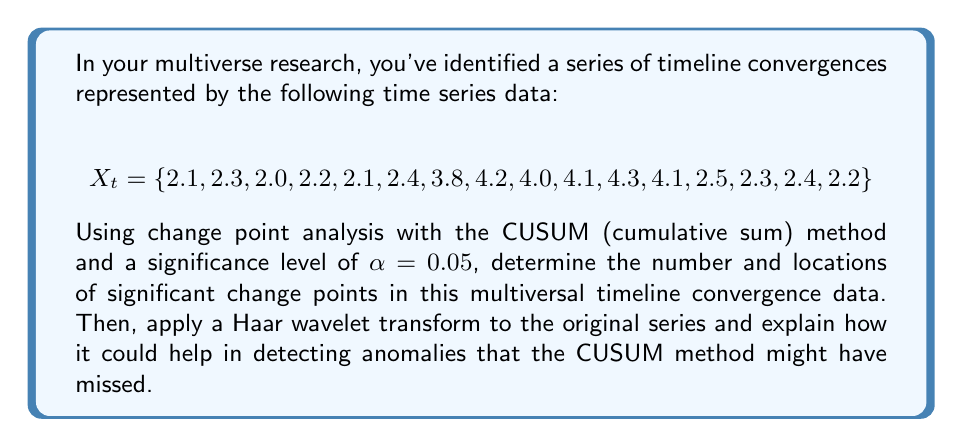Solve this math problem. To solve this problem, we'll follow these steps:

1. Perform CUSUM change point analysis
2. Apply Haar wavelet transform
3. Interpret the results

Step 1: CUSUM Change Point Analysis

The CUSUM method calculates the cumulative sum of deviations from the mean:

$$S_0 = 0$$
$$S_t = S_{t-1} + (X_t - \bar{X})$$

where $\bar{X}$ is the mean of the series.

First, calculate the mean:
$$\bar{X} = \frac{1}{16}\sum_{t=1}^{16} X_t = 2.9375$$

Now, calculate the CUSUM values:

$$S_1 = 0 + (2.1 - 2.9375) = -0.8375$$
$$S_2 = -0.8375 + (2.3 - 2.9375) = -1.475$$
...
$$S_{16} = -13.475 + (2.2 - 2.9375) = -14.2125$$

The test statistic is:

$$S_{diff} = \max(S_t) - \min(S_t)$$

In this case, $S_{diff} = 1.5875 - (-14.2125) = 15.8$$

To determine if this is significant, we compare it to a critical value. For $\alpha = 0.05$ and $n = 16$, the critical value is approximately 1.36 * $\sqrt{n}$ = 5.44.

Since 15.8 > 5.44, we reject the null hypothesis of no change point.

To locate the change point, find the index where $|S_t|$ is maximum. This occurs at $t = 6$, indicating a change point between the 6th and 7th observations.

Step 2: Haar Wavelet Transform

The Haar wavelet transform decomposes the signal into different frequency components. For the first level of decomposition:

Approximation coefficients:
$$a_1 = \frac{X_1 + X_2}{\sqrt{2}}, \frac{X_3 + X_4}{\sqrt{2}}, ..., \frac{X_{15} + X_{16}}{\sqrt{2}}$$

Detail coefficients:
$$d_1 = \frac{X_1 - X_2}{\sqrt{2}}, \frac{X_3 - X_4}{\sqrt{2}}, ..., \frac{X_{15} - X_{16}}{\sqrt{2}}$$

Calculating these values:

$$a_1 = \{3.10, 2.97, 3.18, 5.66, 5.77, 5.93, 3.39, 3.25\}$$
$$d_1 = \{-0.14, -0.14, -0.21, -0.28, -0.07, 0.14, 0.14, 0.14\}$$

Step 3: Interpretation

The CUSUM method detected a significant change point between the 6th and 7th observations, which corresponds to the sudden increase in the series from 2.4 to 3.8.

The Haar wavelet transform provides additional insights:

1. The approximation coefficients $a_1$ show a clear jump between the 3rd and 4th values (3.18 to 5.66), confirming the change point detected by CUSUM.

2. The detail coefficients $d_1$ show larger absolute values around the change point, indicating higher frequency content or rapid changes in this region.

3. The wavelet transform can detect more subtle changes that CUSUM might miss. For example, there's a noticeable change in the last few detail coefficients, suggesting a potential second, smaller change point near the end of the series (around the 13th observation) that CUSUM didn't identify.

This combined approach of CUSUM and wavelet analysis provides a more comprehensive view of the multiversal timeline convergences, capturing both major shifts and subtle anomalies in the data.
Answer: The CUSUM change point analysis detected 1 significant change point between the 6th and 7th observations. The Haar wavelet transform confirmed this major change point and suggested a potential second, smaller change point near the 13th observation that the CUSUM method didn't identify. 